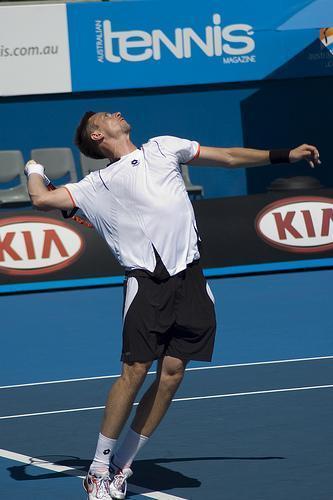How many men holding the racket?
Give a very brief answer. 1. How many tennis balls are there?
Give a very brief answer. 0. 